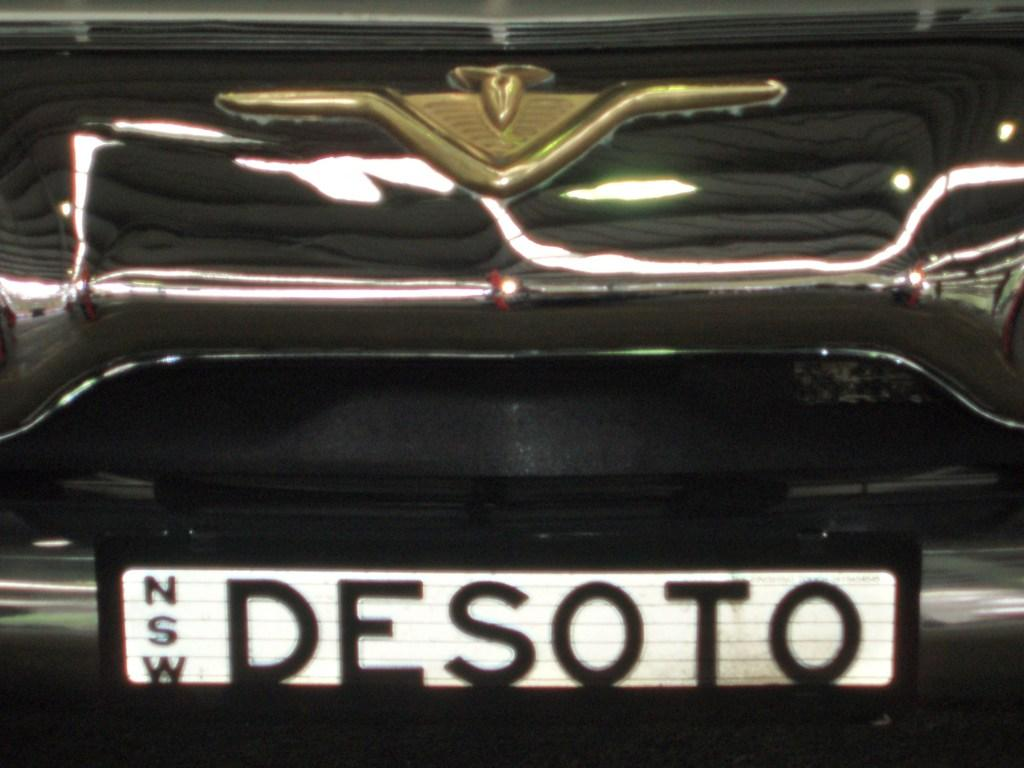<image>
Present a compact description of the photo's key features. A black vehicle with Desoto as its license plate. 